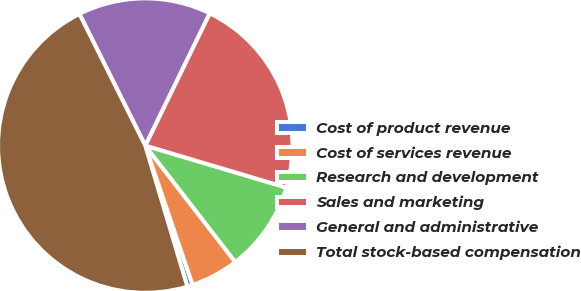<chart> <loc_0><loc_0><loc_500><loc_500><pie_chart><fcel>Cost of product revenue<fcel>Cost of services revenue<fcel>Research and development<fcel>Sales and marketing<fcel>General and administrative<fcel>Total stock-based compensation<nl><fcel>0.6%<fcel>5.26%<fcel>9.92%<fcel>22.39%<fcel>14.59%<fcel>47.24%<nl></chart> 